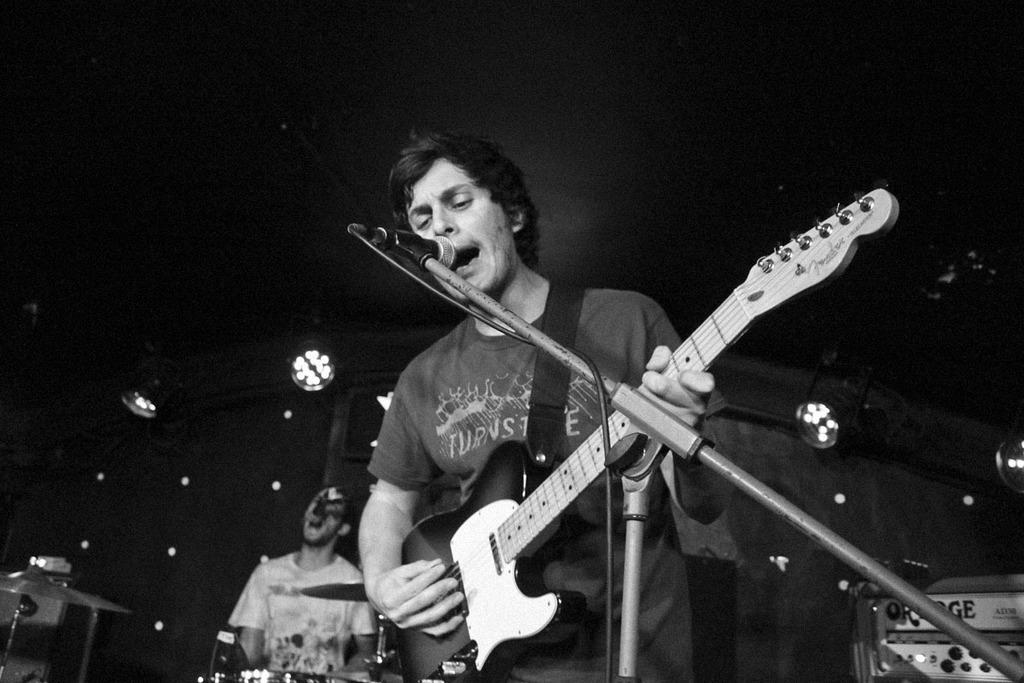How many people are in the image? There are two people in the image. What are the two people doing in the image? One man is holding a guitar, and the other man is playing musical drums. What can be seen at the top of the image? There are lights visible at the top of the image. What type of sleet can be seen falling on the guitar in the image? There is no sleet present in the image, and the guitar is not being affected by any weather conditions. Can you tell me the name of the daughter of the man playing the drums? There is no information about the man's daughter in the image, and we cannot determine her name based on the provided facts. 